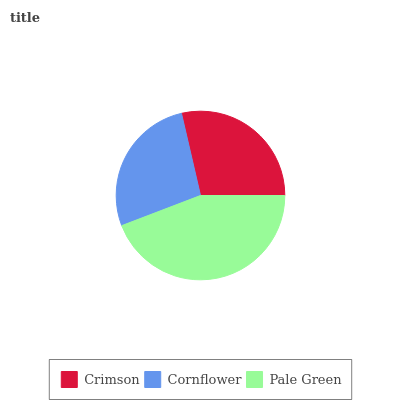Is Cornflower the minimum?
Answer yes or no. Yes. Is Pale Green the maximum?
Answer yes or no. Yes. Is Pale Green the minimum?
Answer yes or no. No. Is Cornflower the maximum?
Answer yes or no. No. Is Pale Green greater than Cornflower?
Answer yes or no. Yes. Is Cornflower less than Pale Green?
Answer yes or no. Yes. Is Cornflower greater than Pale Green?
Answer yes or no. No. Is Pale Green less than Cornflower?
Answer yes or no. No. Is Crimson the high median?
Answer yes or no. Yes. Is Crimson the low median?
Answer yes or no. Yes. Is Pale Green the high median?
Answer yes or no. No. Is Pale Green the low median?
Answer yes or no. No. 